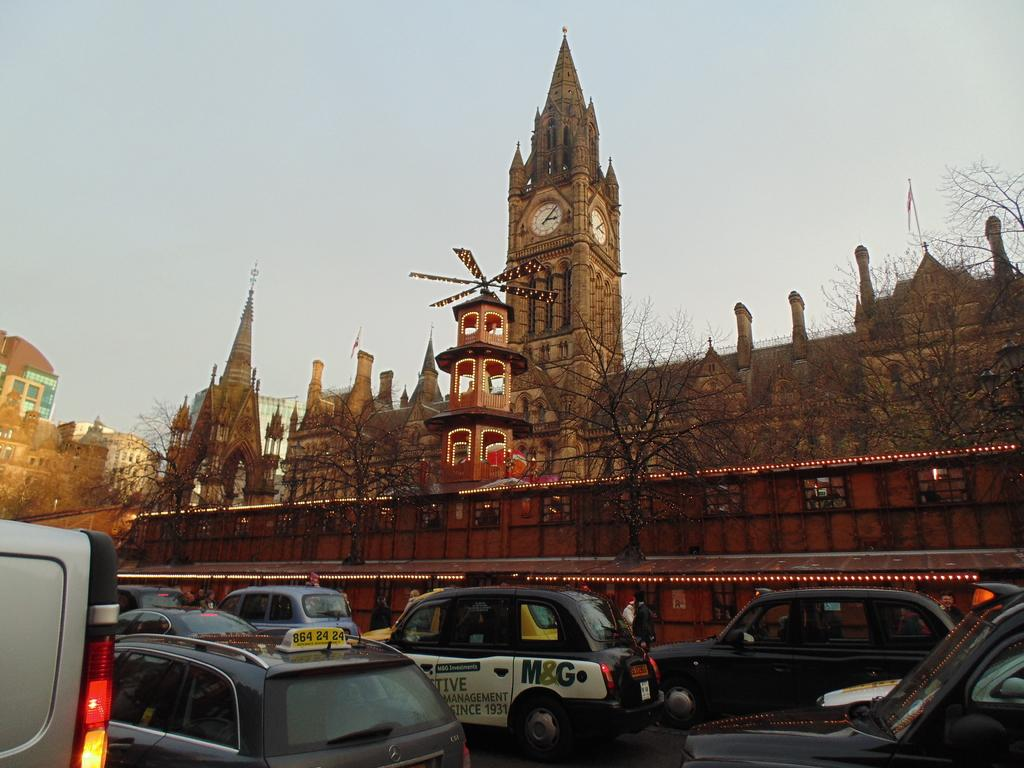What can be seen on the road in the image? There are vehicles on the road in the image. What type of natural elements are present in the image? There are trees in the image. What type of man-made structures can be seen in the image? There are buildings in the image. What type of illumination is present in the image? There are lights in the image. What other objects can be seen in the image? There are some objects in the image. What is visible in the background of the image? The sky is visible in the background of the image. How many rabbits can be seen eating straw in the image? There are no rabbits or straw present in the image. What type of slip can be seen on the road in the image? There is no slip visible on the road in the image. 